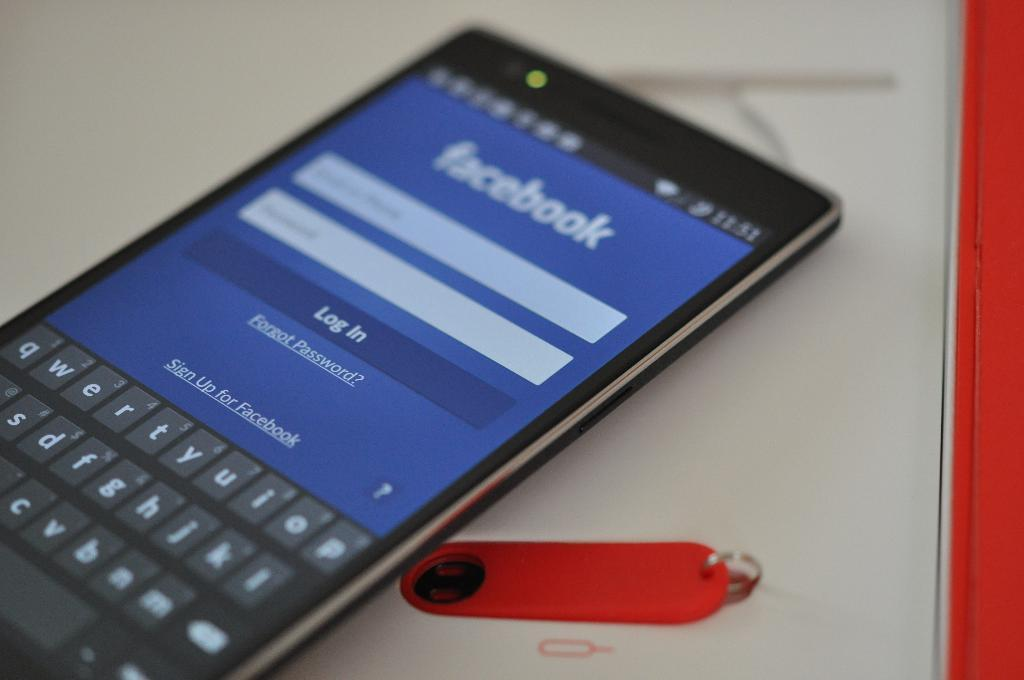<image>
Render a clear and concise summary of the photo. a black cell phone open to a display of FACEBOOK Log In page 